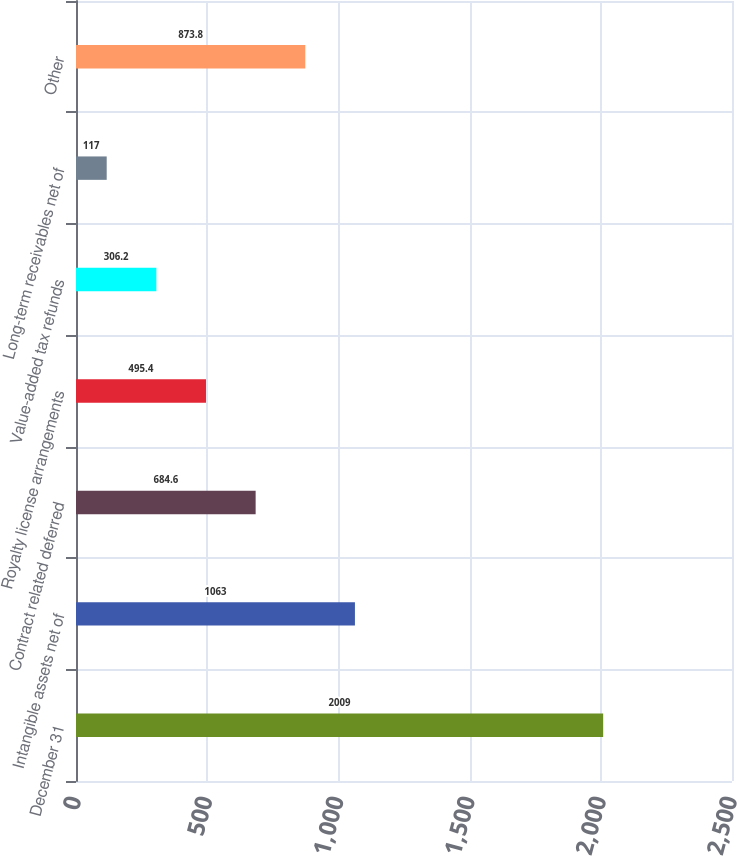Convert chart to OTSL. <chart><loc_0><loc_0><loc_500><loc_500><bar_chart><fcel>December 31<fcel>Intangible assets net of<fcel>Contract related deferred<fcel>Royalty license arrangements<fcel>Value-added tax refunds<fcel>Long-term receivables net of<fcel>Other<nl><fcel>2009<fcel>1063<fcel>684.6<fcel>495.4<fcel>306.2<fcel>117<fcel>873.8<nl></chart> 